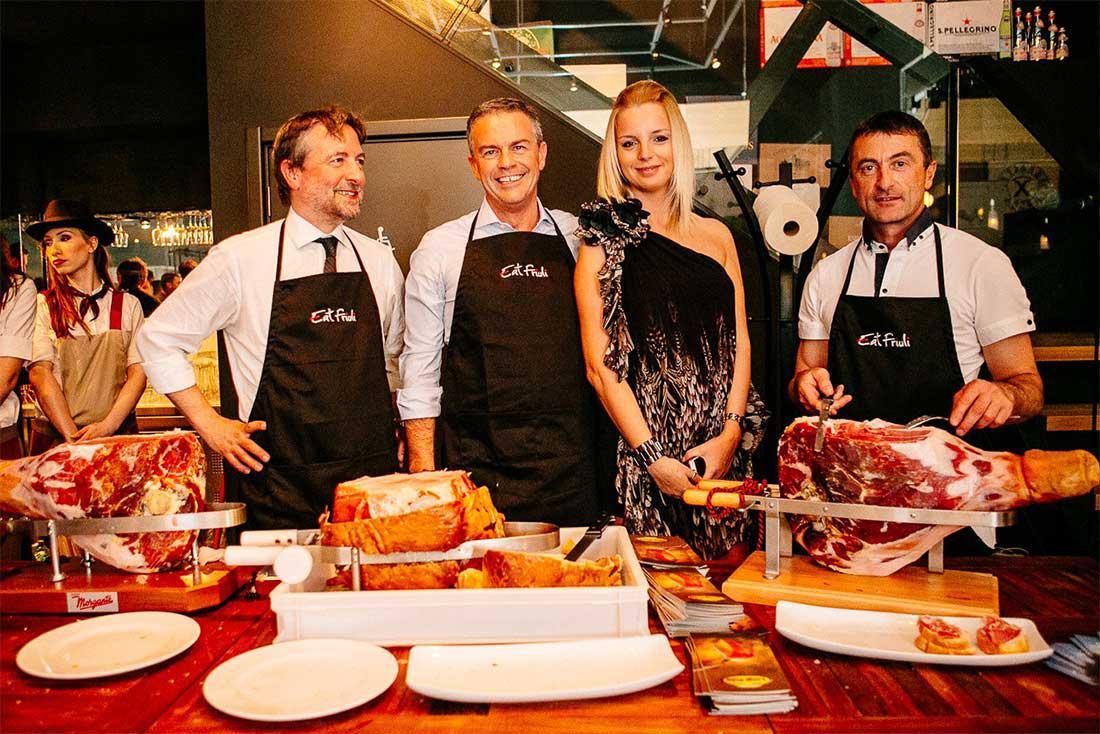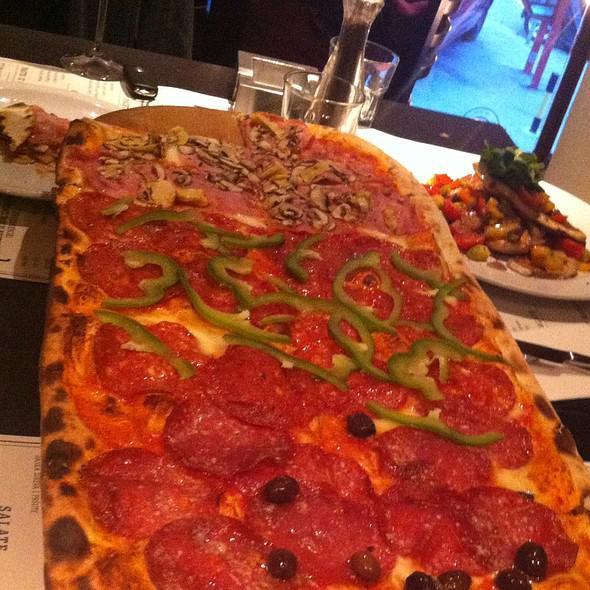The first image is the image on the left, the second image is the image on the right. Analyze the images presented: Is the assertion "In one of the images, a very long pizza appears to have three sections, with different toppings in each of the sections." valid? Answer yes or no. Yes. The first image is the image on the left, the second image is the image on the right. Assess this claim about the two images: "The left image features someone sitting at a wooden table behind a round pizza, with a glass of amber beverage next to the pizza.". Correct or not? Answer yes or no. No. 